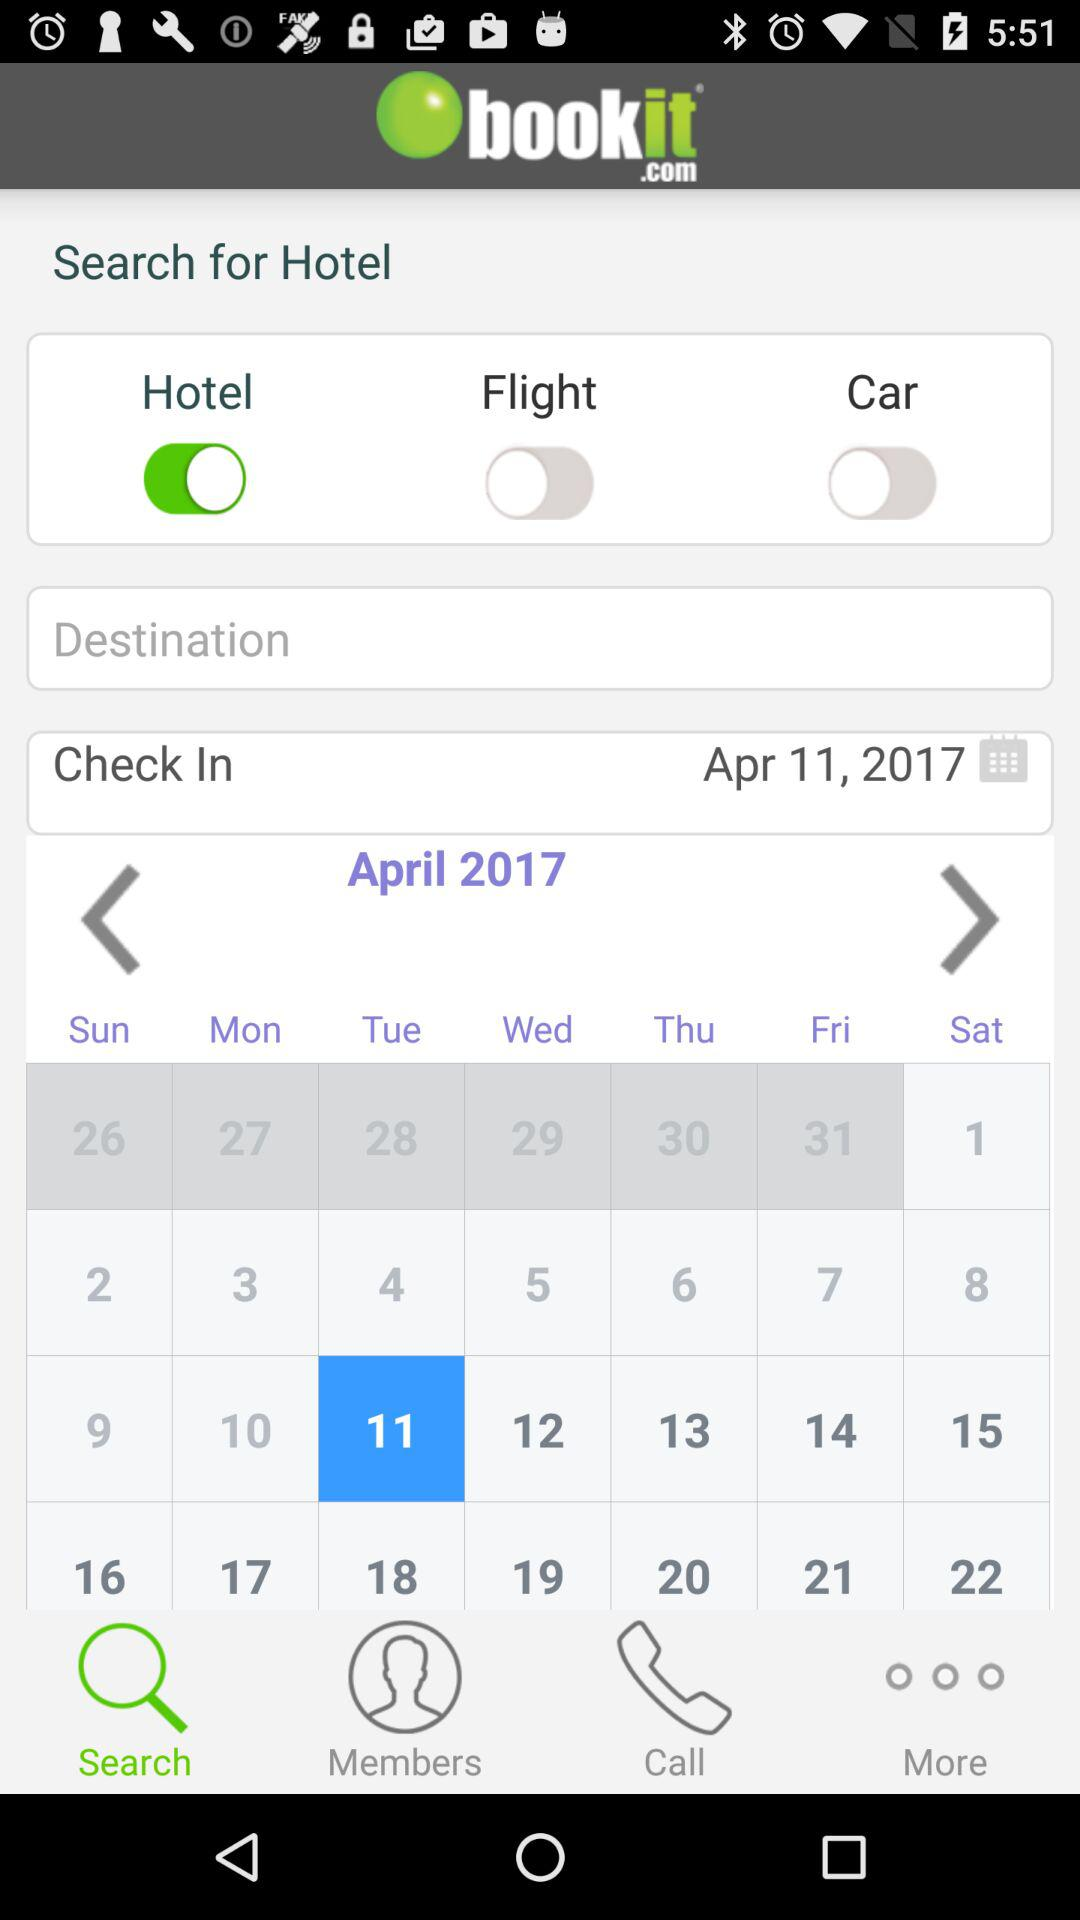What is the status of "Hotel"? The status is "on". 